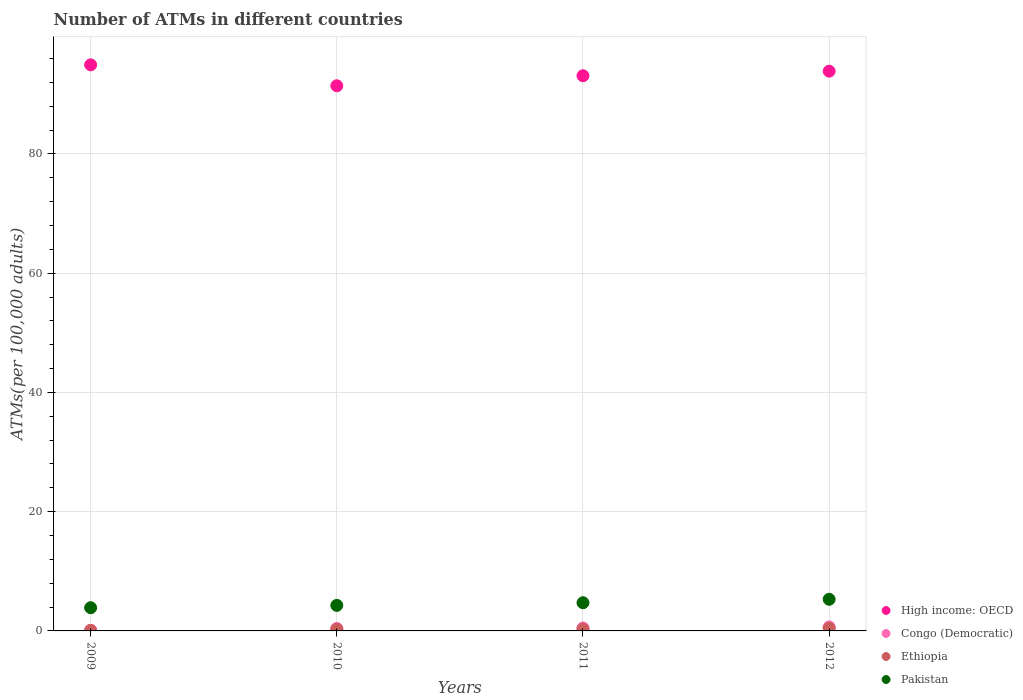How many different coloured dotlines are there?
Offer a very short reply. 4. What is the number of ATMs in Congo (Democratic) in 2012?
Your response must be concise. 0.67. Across all years, what is the maximum number of ATMs in Pakistan?
Ensure brevity in your answer.  5.31. Across all years, what is the minimum number of ATMs in Pakistan?
Provide a succinct answer. 3.89. In which year was the number of ATMs in High income: OECD maximum?
Ensure brevity in your answer.  2009. In which year was the number of ATMs in Congo (Democratic) minimum?
Ensure brevity in your answer.  2009. What is the total number of ATMs in Congo (Democratic) in the graph?
Ensure brevity in your answer.  1.69. What is the difference between the number of ATMs in Ethiopia in 2009 and that in 2010?
Offer a terse response. -0.2. What is the difference between the number of ATMs in Pakistan in 2011 and the number of ATMs in Ethiopia in 2010?
Ensure brevity in your answer.  4.43. What is the average number of ATMs in Ethiopia per year?
Your answer should be compact. 0.3. In the year 2009, what is the difference between the number of ATMs in Pakistan and number of ATMs in High income: OECD?
Offer a terse response. -91.05. In how many years, is the number of ATMs in Ethiopia greater than 16?
Offer a very short reply. 0. What is the ratio of the number of ATMs in Ethiopia in 2010 to that in 2012?
Ensure brevity in your answer.  0.65. Is the number of ATMs in Ethiopia in 2010 less than that in 2012?
Provide a short and direct response. Yes. What is the difference between the highest and the second highest number of ATMs in Pakistan?
Ensure brevity in your answer.  0.58. What is the difference between the highest and the lowest number of ATMs in High income: OECD?
Give a very brief answer. 3.51. In how many years, is the number of ATMs in Pakistan greater than the average number of ATMs in Pakistan taken over all years?
Make the answer very short. 2. Is it the case that in every year, the sum of the number of ATMs in Congo (Democratic) and number of ATMs in Ethiopia  is greater than the sum of number of ATMs in High income: OECD and number of ATMs in Pakistan?
Provide a succinct answer. No. Does the number of ATMs in High income: OECD monotonically increase over the years?
Your response must be concise. No. How many dotlines are there?
Provide a succinct answer. 4. What is the difference between two consecutive major ticks on the Y-axis?
Give a very brief answer. 20. Are the values on the major ticks of Y-axis written in scientific E-notation?
Provide a short and direct response. No. Does the graph contain any zero values?
Offer a terse response. No. Does the graph contain grids?
Offer a very short reply. Yes. Where does the legend appear in the graph?
Offer a terse response. Bottom right. How many legend labels are there?
Offer a very short reply. 4. What is the title of the graph?
Provide a succinct answer. Number of ATMs in different countries. What is the label or title of the Y-axis?
Your response must be concise. ATMs(per 100,0 adults). What is the ATMs(per 100,000 adults) of High income: OECD in 2009?
Provide a short and direct response. 94.95. What is the ATMs(per 100,000 adults) in Congo (Democratic) in 2009?
Provide a short and direct response. 0.1. What is the ATMs(per 100,000 adults) in Ethiopia in 2009?
Ensure brevity in your answer.  0.1. What is the ATMs(per 100,000 adults) in Pakistan in 2009?
Offer a very short reply. 3.89. What is the ATMs(per 100,000 adults) in High income: OECD in 2010?
Your answer should be very brief. 91.44. What is the ATMs(per 100,000 adults) of Congo (Democratic) in 2010?
Offer a very short reply. 0.42. What is the ATMs(per 100,000 adults) of Ethiopia in 2010?
Make the answer very short. 0.3. What is the ATMs(per 100,000 adults) in Pakistan in 2010?
Make the answer very short. 4.28. What is the ATMs(per 100,000 adults) in High income: OECD in 2011?
Keep it short and to the point. 93.12. What is the ATMs(per 100,000 adults) of Congo (Democratic) in 2011?
Offer a terse response. 0.5. What is the ATMs(per 100,000 adults) of Ethiopia in 2011?
Ensure brevity in your answer.  0.32. What is the ATMs(per 100,000 adults) in Pakistan in 2011?
Your response must be concise. 4.73. What is the ATMs(per 100,000 adults) of High income: OECD in 2012?
Offer a very short reply. 93.88. What is the ATMs(per 100,000 adults) of Congo (Democratic) in 2012?
Offer a terse response. 0.67. What is the ATMs(per 100,000 adults) in Ethiopia in 2012?
Offer a very short reply. 0.46. What is the ATMs(per 100,000 adults) in Pakistan in 2012?
Your answer should be very brief. 5.31. Across all years, what is the maximum ATMs(per 100,000 adults) of High income: OECD?
Make the answer very short. 94.95. Across all years, what is the maximum ATMs(per 100,000 adults) in Congo (Democratic)?
Provide a succinct answer. 0.67. Across all years, what is the maximum ATMs(per 100,000 adults) in Ethiopia?
Provide a succinct answer. 0.46. Across all years, what is the maximum ATMs(per 100,000 adults) in Pakistan?
Ensure brevity in your answer.  5.31. Across all years, what is the minimum ATMs(per 100,000 adults) of High income: OECD?
Provide a succinct answer. 91.44. Across all years, what is the minimum ATMs(per 100,000 adults) in Congo (Democratic)?
Provide a short and direct response. 0.1. Across all years, what is the minimum ATMs(per 100,000 adults) of Ethiopia?
Your answer should be very brief. 0.1. Across all years, what is the minimum ATMs(per 100,000 adults) in Pakistan?
Make the answer very short. 3.89. What is the total ATMs(per 100,000 adults) of High income: OECD in the graph?
Ensure brevity in your answer.  373.39. What is the total ATMs(per 100,000 adults) of Congo (Democratic) in the graph?
Provide a succinct answer. 1.69. What is the total ATMs(per 100,000 adults) in Ethiopia in the graph?
Provide a short and direct response. 1.18. What is the total ATMs(per 100,000 adults) in Pakistan in the graph?
Your response must be concise. 18.21. What is the difference between the ATMs(per 100,000 adults) of High income: OECD in 2009 and that in 2010?
Your response must be concise. 3.51. What is the difference between the ATMs(per 100,000 adults) in Congo (Democratic) in 2009 and that in 2010?
Provide a short and direct response. -0.32. What is the difference between the ATMs(per 100,000 adults) in Ethiopia in 2009 and that in 2010?
Offer a very short reply. -0.2. What is the difference between the ATMs(per 100,000 adults) in Pakistan in 2009 and that in 2010?
Provide a succinct answer. -0.39. What is the difference between the ATMs(per 100,000 adults) in High income: OECD in 2009 and that in 2011?
Give a very brief answer. 1.83. What is the difference between the ATMs(per 100,000 adults) of Congo (Democratic) in 2009 and that in 2011?
Your answer should be compact. -0.4. What is the difference between the ATMs(per 100,000 adults) of Ethiopia in 2009 and that in 2011?
Give a very brief answer. -0.22. What is the difference between the ATMs(per 100,000 adults) in Pakistan in 2009 and that in 2011?
Your answer should be very brief. -0.84. What is the difference between the ATMs(per 100,000 adults) of High income: OECD in 2009 and that in 2012?
Make the answer very short. 1.06. What is the difference between the ATMs(per 100,000 adults) of Congo (Democratic) in 2009 and that in 2012?
Provide a succinct answer. -0.57. What is the difference between the ATMs(per 100,000 adults) of Ethiopia in 2009 and that in 2012?
Your response must be concise. -0.36. What is the difference between the ATMs(per 100,000 adults) in Pakistan in 2009 and that in 2012?
Your response must be concise. -1.41. What is the difference between the ATMs(per 100,000 adults) in High income: OECD in 2010 and that in 2011?
Keep it short and to the point. -1.68. What is the difference between the ATMs(per 100,000 adults) in Congo (Democratic) in 2010 and that in 2011?
Offer a terse response. -0.08. What is the difference between the ATMs(per 100,000 adults) of Ethiopia in 2010 and that in 2011?
Your answer should be compact. -0.02. What is the difference between the ATMs(per 100,000 adults) in Pakistan in 2010 and that in 2011?
Keep it short and to the point. -0.45. What is the difference between the ATMs(per 100,000 adults) in High income: OECD in 2010 and that in 2012?
Provide a succinct answer. -2.45. What is the difference between the ATMs(per 100,000 adults) in Congo (Democratic) in 2010 and that in 2012?
Provide a short and direct response. -0.26. What is the difference between the ATMs(per 100,000 adults) of Ethiopia in 2010 and that in 2012?
Give a very brief answer. -0.16. What is the difference between the ATMs(per 100,000 adults) of Pakistan in 2010 and that in 2012?
Your response must be concise. -1.02. What is the difference between the ATMs(per 100,000 adults) of High income: OECD in 2011 and that in 2012?
Offer a terse response. -0.77. What is the difference between the ATMs(per 100,000 adults) in Congo (Democratic) in 2011 and that in 2012?
Offer a very short reply. -0.17. What is the difference between the ATMs(per 100,000 adults) in Ethiopia in 2011 and that in 2012?
Your response must be concise. -0.14. What is the difference between the ATMs(per 100,000 adults) of Pakistan in 2011 and that in 2012?
Ensure brevity in your answer.  -0.58. What is the difference between the ATMs(per 100,000 adults) of High income: OECD in 2009 and the ATMs(per 100,000 adults) of Congo (Democratic) in 2010?
Provide a succinct answer. 94.53. What is the difference between the ATMs(per 100,000 adults) in High income: OECD in 2009 and the ATMs(per 100,000 adults) in Ethiopia in 2010?
Your answer should be very brief. 94.65. What is the difference between the ATMs(per 100,000 adults) in High income: OECD in 2009 and the ATMs(per 100,000 adults) in Pakistan in 2010?
Offer a very short reply. 90.67. What is the difference between the ATMs(per 100,000 adults) in Congo (Democratic) in 2009 and the ATMs(per 100,000 adults) in Ethiopia in 2010?
Offer a very short reply. -0.2. What is the difference between the ATMs(per 100,000 adults) in Congo (Democratic) in 2009 and the ATMs(per 100,000 adults) in Pakistan in 2010?
Keep it short and to the point. -4.18. What is the difference between the ATMs(per 100,000 adults) in Ethiopia in 2009 and the ATMs(per 100,000 adults) in Pakistan in 2010?
Your answer should be compact. -4.18. What is the difference between the ATMs(per 100,000 adults) in High income: OECD in 2009 and the ATMs(per 100,000 adults) in Congo (Democratic) in 2011?
Offer a terse response. 94.45. What is the difference between the ATMs(per 100,000 adults) of High income: OECD in 2009 and the ATMs(per 100,000 adults) of Ethiopia in 2011?
Your answer should be very brief. 94.63. What is the difference between the ATMs(per 100,000 adults) in High income: OECD in 2009 and the ATMs(per 100,000 adults) in Pakistan in 2011?
Make the answer very short. 90.22. What is the difference between the ATMs(per 100,000 adults) in Congo (Democratic) in 2009 and the ATMs(per 100,000 adults) in Ethiopia in 2011?
Give a very brief answer. -0.22. What is the difference between the ATMs(per 100,000 adults) of Congo (Democratic) in 2009 and the ATMs(per 100,000 adults) of Pakistan in 2011?
Your response must be concise. -4.63. What is the difference between the ATMs(per 100,000 adults) in Ethiopia in 2009 and the ATMs(per 100,000 adults) in Pakistan in 2011?
Offer a terse response. -4.63. What is the difference between the ATMs(per 100,000 adults) of High income: OECD in 2009 and the ATMs(per 100,000 adults) of Congo (Democratic) in 2012?
Provide a short and direct response. 94.28. What is the difference between the ATMs(per 100,000 adults) in High income: OECD in 2009 and the ATMs(per 100,000 adults) in Ethiopia in 2012?
Provide a succinct answer. 94.48. What is the difference between the ATMs(per 100,000 adults) of High income: OECD in 2009 and the ATMs(per 100,000 adults) of Pakistan in 2012?
Your answer should be compact. 89.64. What is the difference between the ATMs(per 100,000 adults) of Congo (Democratic) in 2009 and the ATMs(per 100,000 adults) of Ethiopia in 2012?
Your response must be concise. -0.36. What is the difference between the ATMs(per 100,000 adults) of Congo (Democratic) in 2009 and the ATMs(per 100,000 adults) of Pakistan in 2012?
Offer a terse response. -5.21. What is the difference between the ATMs(per 100,000 adults) in Ethiopia in 2009 and the ATMs(per 100,000 adults) in Pakistan in 2012?
Ensure brevity in your answer.  -5.21. What is the difference between the ATMs(per 100,000 adults) of High income: OECD in 2010 and the ATMs(per 100,000 adults) of Congo (Democratic) in 2011?
Keep it short and to the point. 90.94. What is the difference between the ATMs(per 100,000 adults) in High income: OECD in 2010 and the ATMs(per 100,000 adults) in Ethiopia in 2011?
Your response must be concise. 91.12. What is the difference between the ATMs(per 100,000 adults) of High income: OECD in 2010 and the ATMs(per 100,000 adults) of Pakistan in 2011?
Your answer should be compact. 86.71. What is the difference between the ATMs(per 100,000 adults) of Congo (Democratic) in 2010 and the ATMs(per 100,000 adults) of Ethiopia in 2011?
Your answer should be very brief. 0.1. What is the difference between the ATMs(per 100,000 adults) of Congo (Democratic) in 2010 and the ATMs(per 100,000 adults) of Pakistan in 2011?
Make the answer very short. -4.31. What is the difference between the ATMs(per 100,000 adults) of Ethiopia in 2010 and the ATMs(per 100,000 adults) of Pakistan in 2011?
Your response must be concise. -4.43. What is the difference between the ATMs(per 100,000 adults) of High income: OECD in 2010 and the ATMs(per 100,000 adults) of Congo (Democratic) in 2012?
Ensure brevity in your answer.  90.77. What is the difference between the ATMs(per 100,000 adults) of High income: OECD in 2010 and the ATMs(per 100,000 adults) of Ethiopia in 2012?
Ensure brevity in your answer.  90.97. What is the difference between the ATMs(per 100,000 adults) in High income: OECD in 2010 and the ATMs(per 100,000 adults) in Pakistan in 2012?
Give a very brief answer. 86.13. What is the difference between the ATMs(per 100,000 adults) of Congo (Democratic) in 2010 and the ATMs(per 100,000 adults) of Ethiopia in 2012?
Your answer should be very brief. -0.05. What is the difference between the ATMs(per 100,000 adults) of Congo (Democratic) in 2010 and the ATMs(per 100,000 adults) of Pakistan in 2012?
Provide a short and direct response. -4.89. What is the difference between the ATMs(per 100,000 adults) in Ethiopia in 2010 and the ATMs(per 100,000 adults) in Pakistan in 2012?
Your response must be concise. -5.01. What is the difference between the ATMs(per 100,000 adults) of High income: OECD in 2011 and the ATMs(per 100,000 adults) of Congo (Democratic) in 2012?
Your response must be concise. 92.45. What is the difference between the ATMs(per 100,000 adults) of High income: OECD in 2011 and the ATMs(per 100,000 adults) of Ethiopia in 2012?
Provide a short and direct response. 92.65. What is the difference between the ATMs(per 100,000 adults) of High income: OECD in 2011 and the ATMs(per 100,000 adults) of Pakistan in 2012?
Offer a terse response. 87.81. What is the difference between the ATMs(per 100,000 adults) in Congo (Democratic) in 2011 and the ATMs(per 100,000 adults) in Ethiopia in 2012?
Make the answer very short. 0.04. What is the difference between the ATMs(per 100,000 adults) of Congo (Democratic) in 2011 and the ATMs(per 100,000 adults) of Pakistan in 2012?
Give a very brief answer. -4.81. What is the difference between the ATMs(per 100,000 adults) in Ethiopia in 2011 and the ATMs(per 100,000 adults) in Pakistan in 2012?
Your response must be concise. -4.99. What is the average ATMs(per 100,000 adults) in High income: OECD per year?
Your answer should be compact. 93.35. What is the average ATMs(per 100,000 adults) of Congo (Democratic) per year?
Provide a succinct answer. 0.42. What is the average ATMs(per 100,000 adults) of Ethiopia per year?
Make the answer very short. 0.3. What is the average ATMs(per 100,000 adults) in Pakistan per year?
Keep it short and to the point. 4.55. In the year 2009, what is the difference between the ATMs(per 100,000 adults) of High income: OECD and ATMs(per 100,000 adults) of Congo (Democratic)?
Give a very brief answer. 94.85. In the year 2009, what is the difference between the ATMs(per 100,000 adults) of High income: OECD and ATMs(per 100,000 adults) of Ethiopia?
Ensure brevity in your answer.  94.85. In the year 2009, what is the difference between the ATMs(per 100,000 adults) in High income: OECD and ATMs(per 100,000 adults) in Pakistan?
Provide a short and direct response. 91.05. In the year 2009, what is the difference between the ATMs(per 100,000 adults) of Congo (Democratic) and ATMs(per 100,000 adults) of Ethiopia?
Offer a terse response. 0. In the year 2009, what is the difference between the ATMs(per 100,000 adults) in Congo (Democratic) and ATMs(per 100,000 adults) in Pakistan?
Make the answer very short. -3.79. In the year 2009, what is the difference between the ATMs(per 100,000 adults) of Ethiopia and ATMs(per 100,000 adults) of Pakistan?
Offer a terse response. -3.79. In the year 2010, what is the difference between the ATMs(per 100,000 adults) of High income: OECD and ATMs(per 100,000 adults) of Congo (Democratic)?
Keep it short and to the point. 91.02. In the year 2010, what is the difference between the ATMs(per 100,000 adults) of High income: OECD and ATMs(per 100,000 adults) of Ethiopia?
Make the answer very short. 91.14. In the year 2010, what is the difference between the ATMs(per 100,000 adults) in High income: OECD and ATMs(per 100,000 adults) in Pakistan?
Your answer should be very brief. 87.16. In the year 2010, what is the difference between the ATMs(per 100,000 adults) of Congo (Democratic) and ATMs(per 100,000 adults) of Ethiopia?
Your answer should be very brief. 0.12. In the year 2010, what is the difference between the ATMs(per 100,000 adults) in Congo (Democratic) and ATMs(per 100,000 adults) in Pakistan?
Provide a short and direct response. -3.87. In the year 2010, what is the difference between the ATMs(per 100,000 adults) of Ethiopia and ATMs(per 100,000 adults) of Pakistan?
Offer a terse response. -3.98. In the year 2011, what is the difference between the ATMs(per 100,000 adults) of High income: OECD and ATMs(per 100,000 adults) of Congo (Democratic)?
Offer a very short reply. 92.62. In the year 2011, what is the difference between the ATMs(per 100,000 adults) of High income: OECD and ATMs(per 100,000 adults) of Ethiopia?
Ensure brevity in your answer.  92.8. In the year 2011, what is the difference between the ATMs(per 100,000 adults) in High income: OECD and ATMs(per 100,000 adults) in Pakistan?
Ensure brevity in your answer.  88.39. In the year 2011, what is the difference between the ATMs(per 100,000 adults) of Congo (Democratic) and ATMs(per 100,000 adults) of Ethiopia?
Provide a short and direct response. 0.18. In the year 2011, what is the difference between the ATMs(per 100,000 adults) in Congo (Democratic) and ATMs(per 100,000 adults) in Pakistan?
Provide a succinct answer. -4.23. In the year 2011, what is the difference between the ATMs(per 100,000 adults) in Ethiopia and ATMs(per 100,000 adults) in Pakistan?
Your answer should be compact. -4.41. In the year 2012, what is the difference between the ATMs(per 100,000 adults) of High income: OECD and ATMs(per 100,000 adults) of Congo (Democratic)?
Provide a short and direct response. 93.21. In the year 2012, what is the difference between the ATMs(per 100,000 adults) of High income: OECD and ATMs(per 100,000 adults) of Ethiopia?
Your answer should be very brief. 93.42. In the year 2012, what is the difference between the ATMs(per 100,000 adults) in High income: OECD and ATMs(per 100,000 adults) in Pakistan?
Give a very brief answer. 88.58. In the year 2012, what is the difference between the ATMs(per 100,000 adults) of Congo (Democratic) and ATMs(per 100,000 adults) of Ethiopia?
Your answer should be very brief. 0.21. In the year 2012, what is the difference between the ATMs(per 100,000 adults) of Congo (Democratic) and ATMs(per 100,000 adults) of Pakistan?
Your answer should be very brief. -4.63. In the year 2012, what is the difference between the ATMs(per 100,000 adults) of Ethiopia and ATMs(per 100,000 adults) of Pakistan?
Make the answer very short. -4.84. What is the ratio of the ATMs(per 100,000 adults) of High income: OECD in 2009 to that in 2010?
Your answer should be very brief. 1.04. What is the ratio of the ATMs(per 100,000 adults) in Congo (Democratic) in 2009 to that in 2010?
Offer a terse response. 0.24. What is the ratio of the ATMs(per 100,000 adults) in Ethiopia in 2009 to that in 2010?
Make the answer very short. 0.33. What is the ratio of the ATMs(per 100,000 adults) of Pakistan in 2009 to that in 2010?
Offer a very short reply. 0.91. What is the ratio of the ATMs(per 100,000 adults) in High income: OECD in 2009 to that in 2011?
Your answer should be very brief. 1.02. What is the ratio of the ATMs(per 100,000 adults) in Congo (Democratic) in 2009 to that in 2011?
Your answer should be compact. 0.2. What is the ratio of the ATMs(per 100,000 adults) in Ethiopia in 2009 to that in 2011?
Your response must be concise. 0.31. What is the ratio of the ATMs(per 100,000 adults) in Pakistan in 2009 to that in 2011?
Provide a short and direct response. 0.82. What is the ratio of the ATMs(per 100,000 adults) in High income: OECD in 2009 to that in 2012?
Provide a short and direct response. 1.01. What is the ratio of the ATMs(per 100,000 adults) of Congo (Democratic) in 2009 to that in 2012?
Your answer should be very brief. 0.15. What is the ratio of the ATMs(per 100,000 adults) in Ethiopia in 2009 to that in 2012?
Offer a very short reply. 0.21. What is the ratio of the ATMs(per 100,000 adults) of Pakistan in 2009 to that in 2012?
Your answer should be compact. 0.73. What is the ratio of the ATMs(per 100,000 adults) of High income: OECD in 2010 to that in 2011?
Your answer should be compact. 0.98. What is the ratio of the ATMs(per 100,000 adults) of Congo (Democratic) in 2010 to that in 2011?
Offer a terse response. 0.83. What is the ratio of the ATMs(per 100,000 adults) of Ethiopia in 2010 to that in 2011?
Make the answer very short. 0.94. What is the ratio of the ATMs(per 100,000 adults) of Pakistan in 2010 to that in 2011?
Offer a very short reply. 0.91. What is the ratio of the ATMs(per 100,000 adults) in High income: OECD in 2010 to that in 2012?
Your answer should be very brief. 0.97. What is the ratio of the ATMs(per 100,000 adults) of Congo (Democratic) in 2010 to that in 2012?
Provide a short and direct response. 0.62. What is the ratio of the ATMs(per 100,000 adults) of Ethiopia in 2010 to that in 2012?
Your answer should be compact. 0.65. What is the ratio of the ATMs(per 100,000 adults) in Pakistan in 2010 to that in 2012?
Keep it short and to the point. 0.81. What is the ratio of the ATMs(per 100,000 adults) in Congo (Democratic) in 2011 to that in 2012?
Give a very brief answer. 0.75. What is the ratio of the ATMs(per 100,000 adults) in Ethiopia in 2011 to that in 2012?
Provide a succinct answer. 0.69. What is the ratio of the ATMs(per 100,000 adults) in Pakistan in 2011 to that in 2012?
Keep it short and to the point. 0.89. What is the difference between the highest and the second highest ATMs(per 100,000 adults) in High income: OECD?
Your response must be concise. 1.06. What is the difference between the highest and the second highest ATMs(per 100,000 adults) in Congo (Democratic)?
Ensure brevity in your answer.  0.17. What is the difference between the highest and the second highest ATMs(per 100,000 adults) in Ethiopia?
Give a very brief answer. 0.14. What is the difference between the highest and the second highest ATMs(per 100,000 adults) in Pakistan?
Provide a short and direct response. 0.58. What is the difference between the highest and the lowest ATMs(per 100,000 adults) in High income: OECD?
Your answer should be compact. 3.51. What is the difference between the highest and the lowest ATMs(per 100,000 adults) of Congo (Democratic)?
Give a very brief answer. 0.57. What is the difference between the highest and the lowest ATMs(per 100,000 adults) in Ethiopia?
Provide a succinct answer. 0.36. What is the difference between the highest and the lowest ATMs(per 100,000 adults) in Pakistan?
Give a very brief answer. 1.41. 